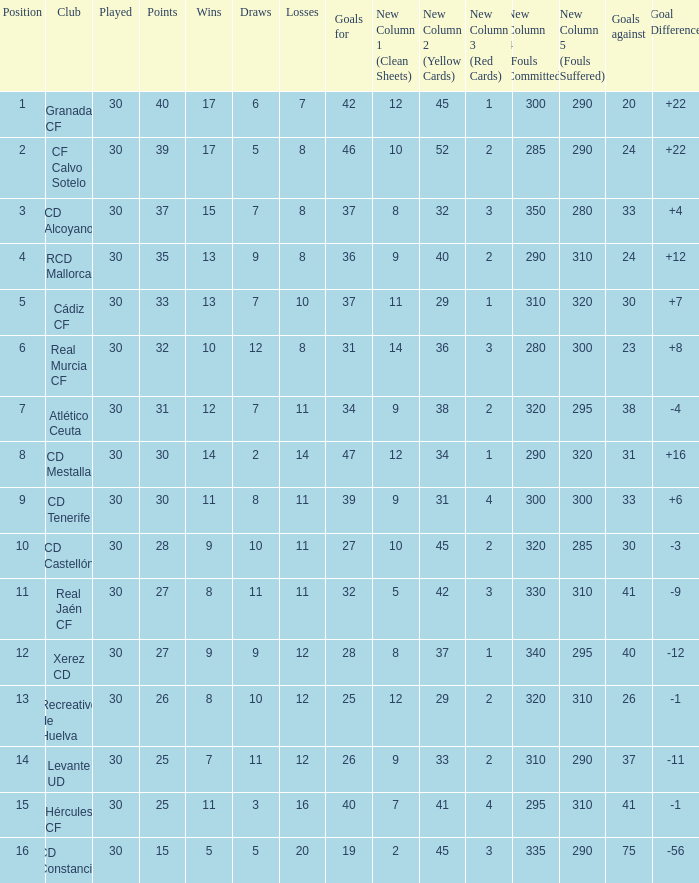How many Draws have 30 Points, and less than 33 Goals against? 1.0. 